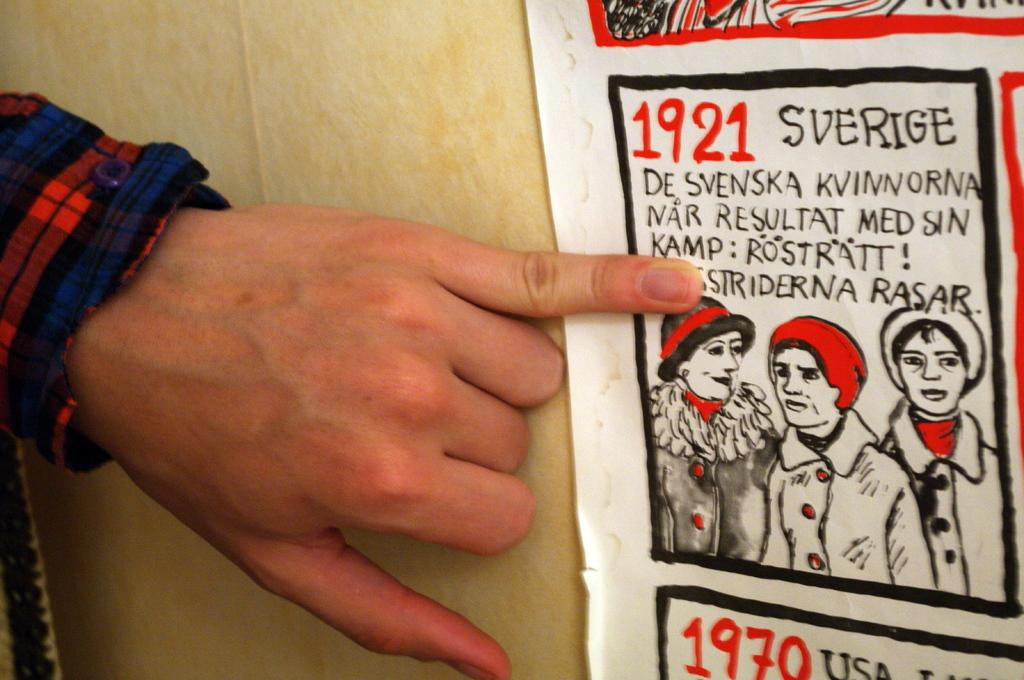What part of a person can be seen in the image? A person's hand is visible in the image. What is on the right side of the image? There is a poster on the right side of the image. What is depicted on the poster? The poster has a painting of people. Is there any text on the poster? Yes, the poster has some text. What are the people in the painting wearing? The people in the painting are wearing caps. What can be seen in the background of the image? There is a wall in the background of the image. How many ants can be seen crawling on the person's hand in the image? There are no ants present on the person's hand in the image. 